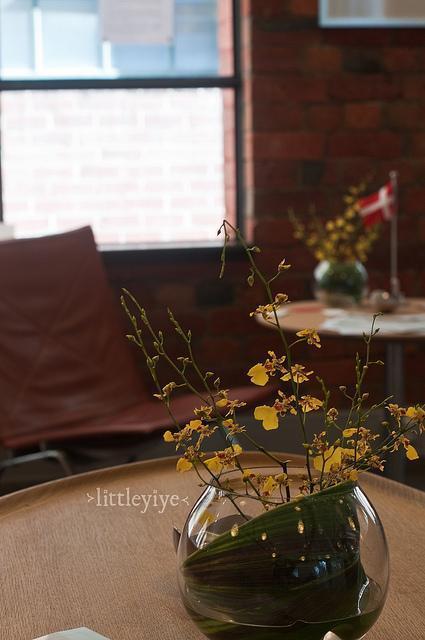How many potted plants are there?
Give a very brief answer. 2. How many vases are visible?
Give a very brief answer. 2. How many people are wearing glasses?
Give a very brief answer. 0. 